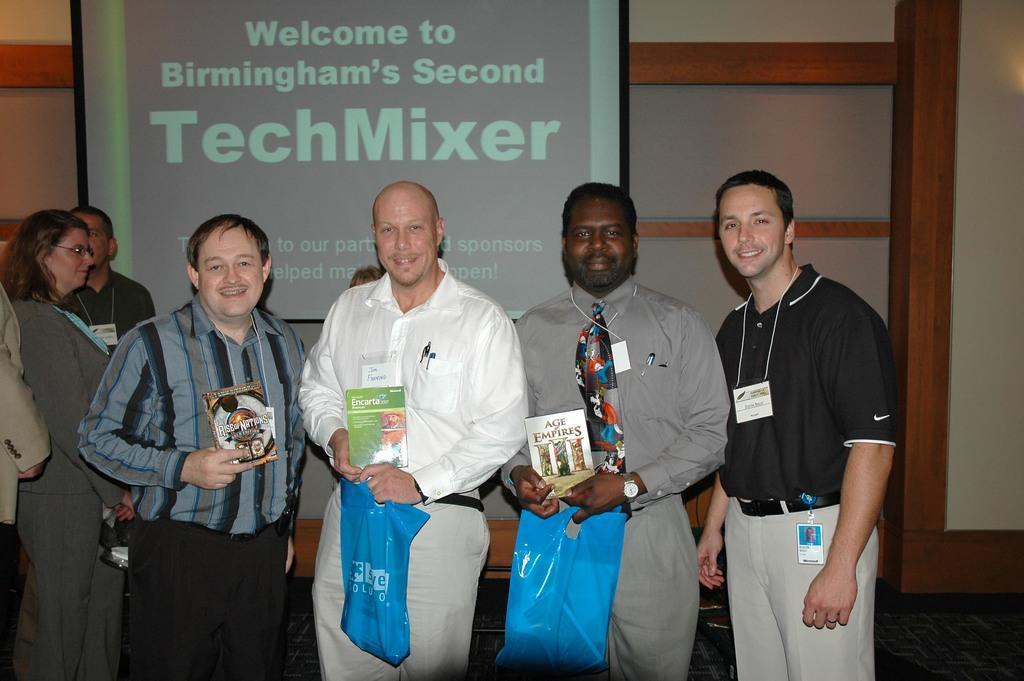Can you describe this image briefly? In this picture we can see a group of people standing and smiling where some are holding books and plastic covers with their hands and in the background we can see a screen. 